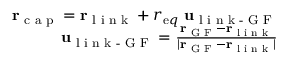<formula> <loc_0><loc_0><loc_500><loc_500>\begin{array} { r } { { r } _ { c a p } = { r } _ { l i n k } + r _ { e q } \ { u } _ { l i n k - G F } } \\ { { u } _ { l i n k - G F } = \frac { { r } _ { G F } - { r } _ { l i n k } } { | { r } _ { G F } - { r } _ { l i n k } | } } \end{array}</formula> 